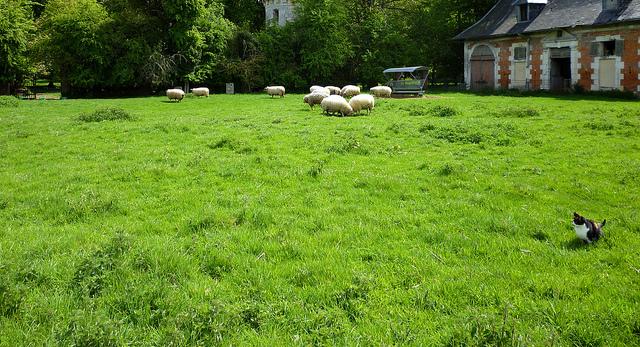How many cats are there?
Keep it brief. 1. What color are all the houses?
Give a very brief answer. Red. Would wolves be problematic for these creatures?
Quick response, please. Yes. How many houses are in this picture?
Short answer required. 2. What color is the grass?
Give a very brief answer. Green. 